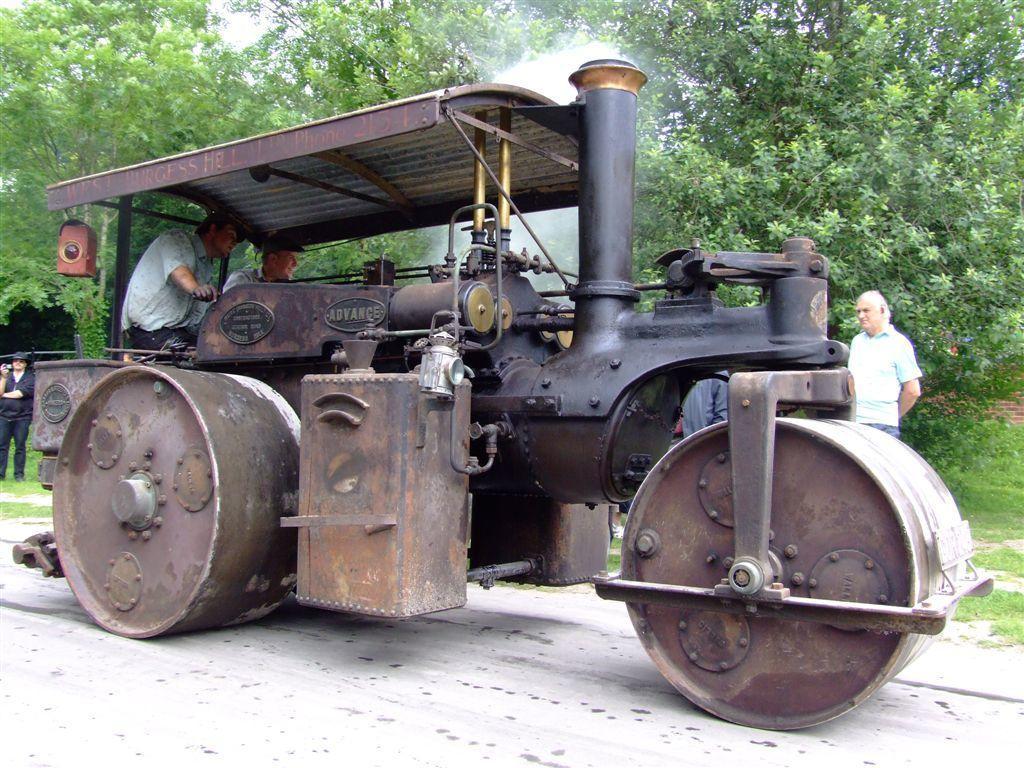Please provide a concise description of this image. In the center of the image there is a road roller and we can see people sitting in it. In the background there are people standing. At the bottom there is a road and we can see trees. 